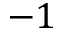Convert formula to latex. <formula><loc_0><loc_0><loc_500><loc_500>- 1</formula> 